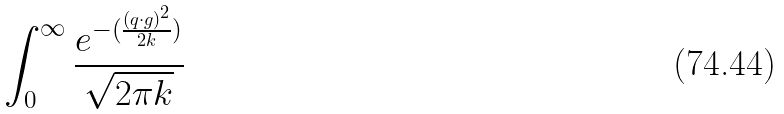<formula> <loc_0><loc_0><loc_500><loc_500>\int _ { 0 } ^ { \infty } \frac { e ^ { - ( \frac { ( q \cdot g ) ^ { 2 } } { 2 k } ) } } { \sqrt { 2 \pi k } }</formula> 